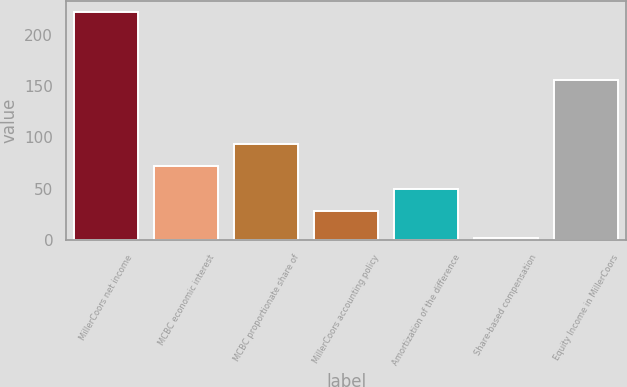Convert chart to OTSL. <chart><loc_0><loc_0><loc_500><loc_500><bar_chart><fcel>MillerCoors net income<fcel>MCBC economic interest<fcel>MCBC proportionate share of<fcel>MillerCoors accounting policy<fcel>Amortization of the difference<fcel>Share-based compensation<fcel>Equity Income in MillerCoors<nl><fcel>222.4<fcel>71.74<fcel>93.76<fcel>27.7<fcel>49.72<fcel>2.2<fcel>155.6<nl></chart> 